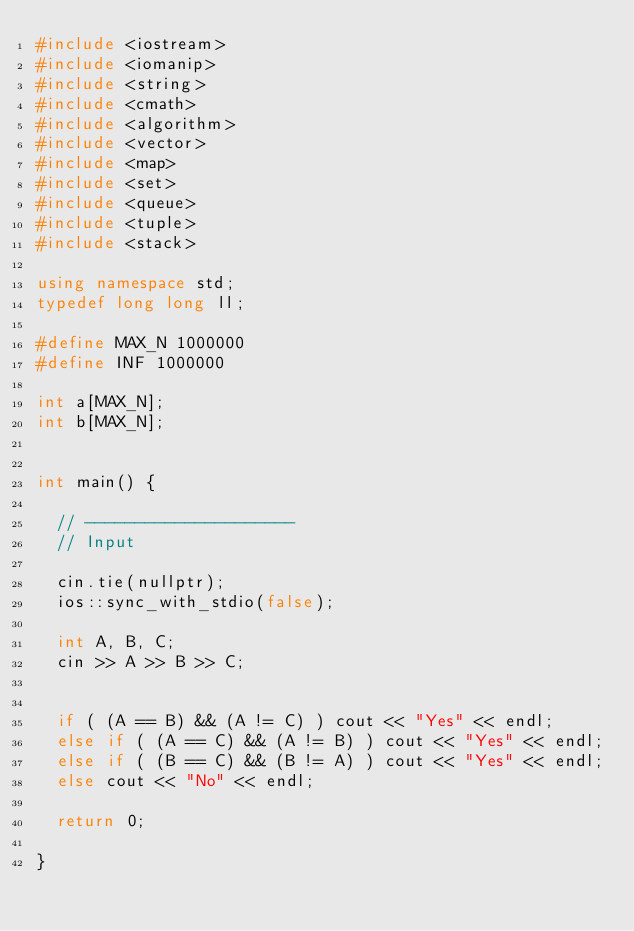Convert code to text. <code><loc_0><loc_0><loc_500><loc_500><_C++_>#include <iostream>
#include <iomanip>
#include <string>
#include <cmath>
#include <algorithm>
#include <vector>
#include <map>
#include <set>
#include <queue>
#include <tuple>
#include <stack>

using namespace std;
typedef long long ll;

#define MAX_N 1000000
#define INF 1000000

int a[MAX_N];
int b[MAX_N];


int main() {

  // ---------------------
  // Input
  
  cin.tie(nullptr);
  ios::sync_with_stdio(false);

  int A, B, C;
  cin >> A >> B >> C;


  if ( (A == B) && (A != C) ) cout << "Yes" << endl;
  else if ( (A == C) && (A != B) ) cout << "Yes" << endl;
  else if ( (B == C) && (B != A) ) cout << "Yes" << endl;
  else cout << "No" << endl;

  return 0;
  
}
</code> 